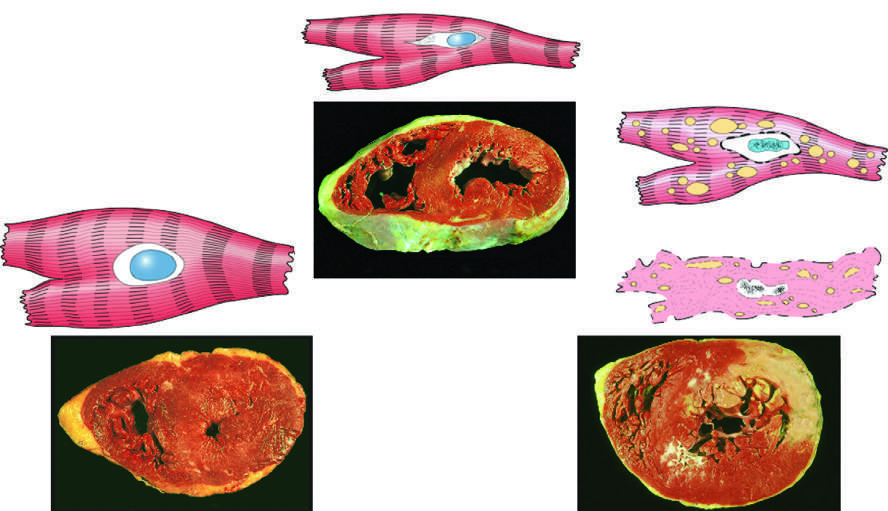what represents an acute myocardial infarction in the specimen showing necrosis?
Answer the question using a single word or phrase. The transmural light area in the posterolateral left ventricle 